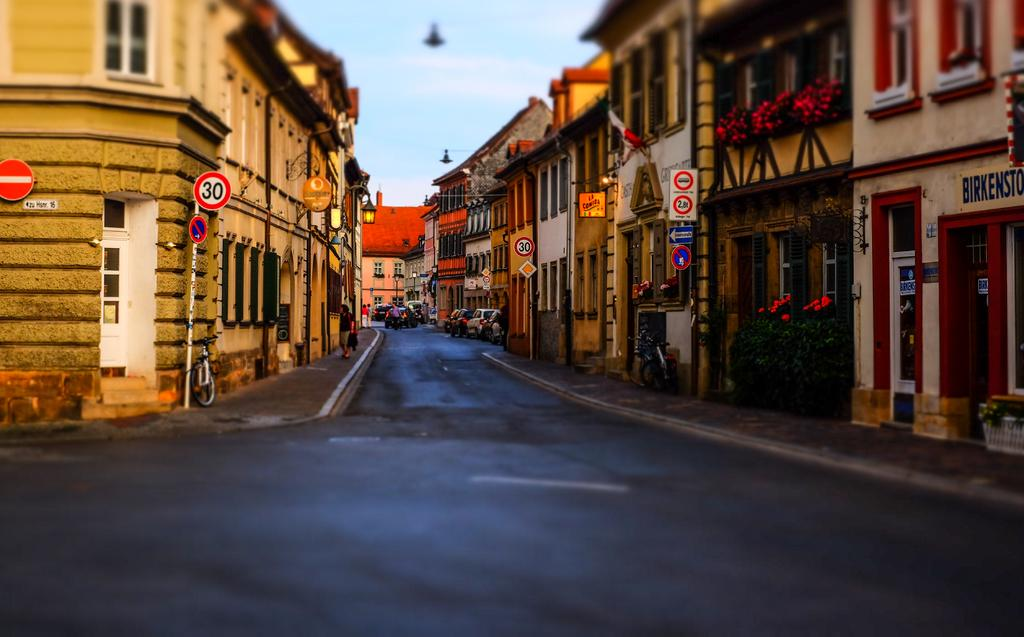What objects in the image? There are boards, poles, vehicles, plants, lights, houses, and a group of people standing in the image. What type of structures can be seen in the image? There are houses in the image. What is the purpose of the poles in the image? The purpose of the poles is not explicitly stated in the facts, but they may be used for supporting structures or providing lighting. What is the natural element present in the image? There are plants in the image. What can be seen in the background of the image? The sky is visible in the background of the image. What type of quiver can be seen flying in the image? There are no quivers or planes visible in the image; it features boards, poles, vehicles, plants, lights, houses, and a group of people standing. How does the group of people start their journey in the image? There is no indication of a journey or any action being taken by the group of people in the image. 